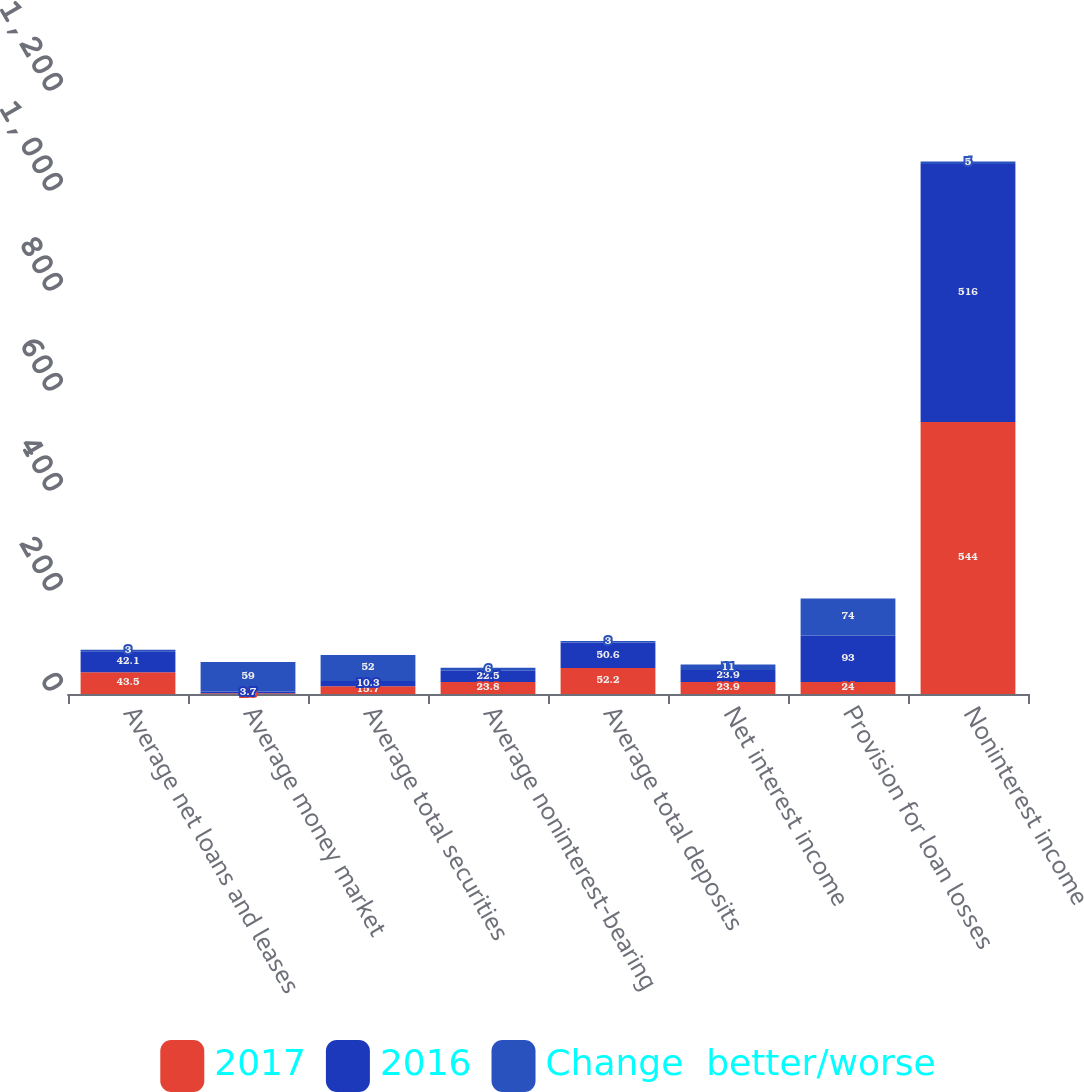<chart> <loc_0><loc_0><loc_500><loc_500><stacked_bar_chart><ecel><fcel>Average net loans and leases<fcel>Average money market<fcel>Average total securities<fcel>Average noninterest-bearing<fcel>Average total deposits<fcel>Net interest income<fcel>Provision for loan losses<fcel>Noninterest income<nl><fcel>2017<fcel>43.5<fcel>1.5<fcel>15.7<fcel>23.8<fcel>52.2<fcel>23.9<fcel>24<fcel>544<nl><fcel>2016<fcel>42.1<fcel>3.7<fcel>10.3<fcel>22.5<fcel>50.6<fcel>23.9<fcel>93<fcel>516<nl><fcel>Change  better/worse<fcel>3<fcel>59<fcel>52<fcel>6<fcel>3<fcel>11<fcel>74<fcel>5<nl></chart> 